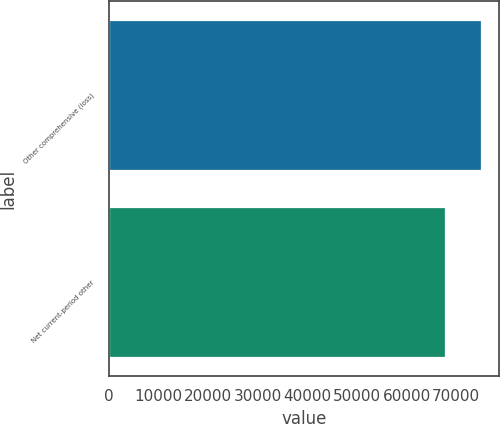Convert chart. <chart><loc_0><loc_0><loc_500><loc_500><bar_chart><fcel>Other comprehensive (loss)<fcel>Net current-period other<nl><fcel>74936<fcel>67806<nl></chart> 